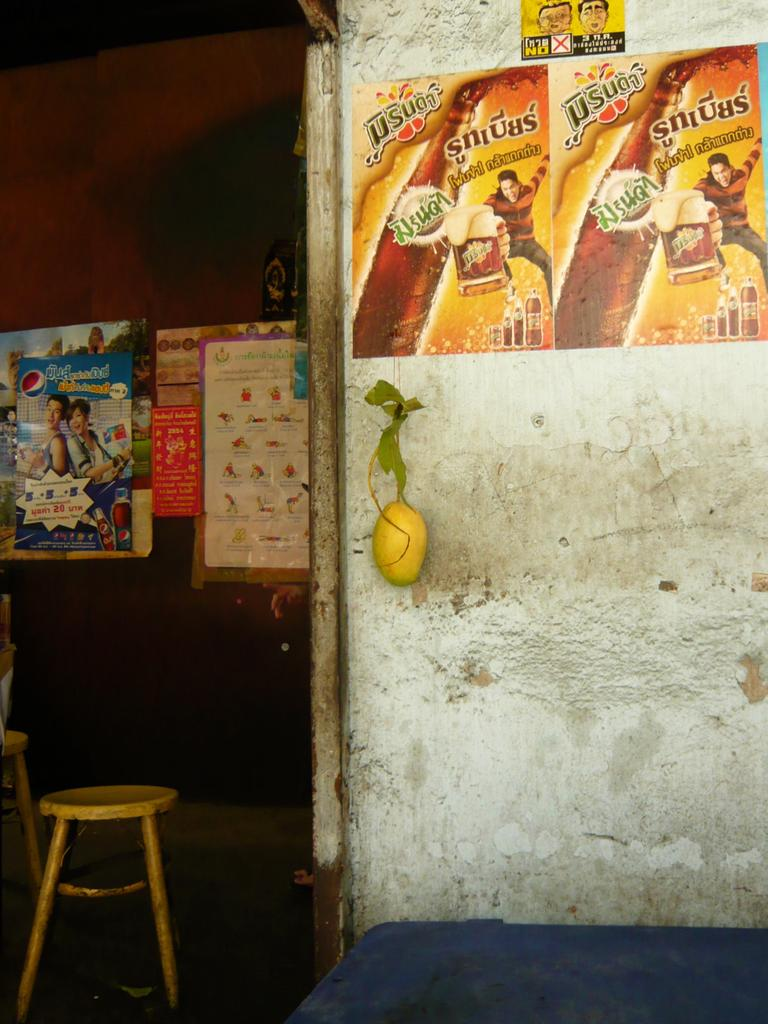What color are the objects that can be seen in the image? There are blue objects in the image. What type of furniture is present in the image? There are chairs in the image. What is hanging on the wall in the image? There are posters on the wall. What type of fruit is visible in the image? There is a mango in the image. What type of vegetation is present in the image? There are leaves in the image. What architectural features can be seen on the wall in the background? There are posts on the wall in the background. What type of tooth is visible in the image? There is: There is no tooth present in the image. What type of ink is used to write on the posters in the image? There is no indication of writing or ink on the posters in the image. 